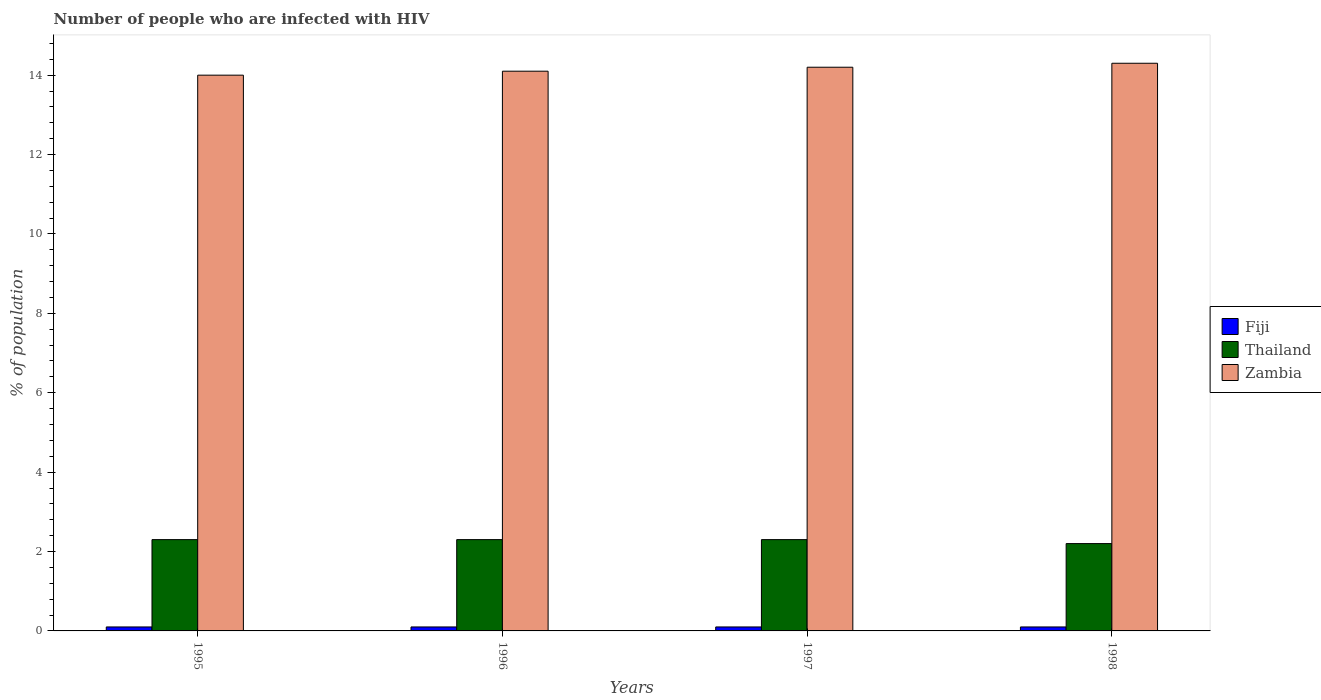How many groups of bars are there?
Keep it short and to the point. 4. Are the number of bars per tick equal to the number of legend labels?
Provide a short and direct response. Yes. Are the number of bars on each tick of the X-axis equal?
Offer a very short reply. Yes. How many bars are there on the 1st tick from the left?
Provide a succinct answer. 3. How many bars are there on the 1st tick from the right?
Offer a terse response. 3. What is the label of the 4th group of bars from the left?
Offer a terse response. 1998. Across all years, what is the maximum percentage of HIV infected population in in Zambia?
Provide a short and direct response. 14.3. Across all years, what is the minimum percentage of HIV infected population in in Zambia?
Keep it short and to the point. 14. In which year was the percentage of HIV infected population in in Thailand maximum?
Your answer should be very brief. 1995. In which year was the percentage of HIV infected population in in Fiji minimum?
Your answer should be compact. 1995. What is the total percentage of HIV infected population in in Fiji in the graph?
Your response must be concise. 0.4. What is the difference between the percentage of HIV infected population in in Fiji in 1995 and that in 1996?
Keep it short and to the point. 0. What is the average percentage of HIV infected population in in Zambia per year?
Your response must be concise. 14.15. In the year 1998, what is the difference between the percentage of HIV infected population in in Thailand and percentage of HIV infected population in in Fiji?
Your answer should be compact. 2.1. What is the ratio of the percentage of HIV infected population in in Fiji in 1995 to that in 1996?
Your response must be concise. 1. Is the difference between the percentage of HIV infected population in in Thailand in 1995 and 1996 greater than the difference between the percentage of HIV infected population in in Fiji in 1995 and 1996?
Ensure brevity in your answer.  No. In how many years, is the percentage of HIV infected population in in Thailand greater than the average percentage of HIV infected population in in Thailand taken over all years?
Ensure brevity in your answer.  3. What does the 1st bar from the left in 1998 represents?
Give a very brief answer. Fiji. What does the 1st bar from the right in 1998 represents?
Provide a short and direct response. Zambia. How many bars are there?
Provide a short and direct response. 12. Are all the bars in the graph horizontal?
Offer a terse response. No. How many years are there in the graph?
Provide a short and direct response. 4. What is the difference between two consecutive major ticks on the Y-axis?
Ensure brevity in your answer.  2. Are the values on the major ticks of Y-axis written in scientific E-notation?
Give a very brief answer. No. Where does the legend appear in the graph?
Offer a terse response. Center right. How are the legend labels stacked?
Offer a very short reply. Vertical. What is the title of the graph?
Offer a terse response. Number of people who are infected with HIV. What is the label or title of the Y-axis?
Keep it short and to the point. % of population. What is the % of population of Zambia in 1995?
Your response must be concise. 14. What is the % of population of Thailand in 1996?
Offer a very short reply. 2.3. What is the % of population in Fiji in 1998?
Your answer should be compact. 0.1. What is the % of population in Thailand in 1998?
Make the answer very short. 2.2. What is the % of population in Zambia in 1998?
Make the answer very short. 14.3. Across all years, what is the maximum % of population of Thailand?
Provide a short and direct response. 2.3. Across all years, what is the maximum % of population of Zambia?
Provide a succinct answer. 14.3. Across all years, what is the minimum % of population of Thailand?
Make the answer very short. 2.2. Across all years, what is the minimum % of population in Zambia?
Your answer should be very brief. 14. What is the total % of population in Fiji in the graph?
Your answer should be very brief. 0.4. What is the total % of population in Zambia in the graph?
Your response must be concise. 56.6. What is the difference between the % of population in Thailand in 1995 and that in 1996?
Make the answer very short. 0. What is the difference between the % of population of Zambia in 1995 and that in 1996?
Your answer should be compact. -0.1. What is the difference between the % of population in Fiji in 1995 and that in 1998?
Your answer should be very brief. 0. What is the difference between the % of population of Thailand in 1995 and that in 1998?
Your answer should be very brief. 0.1. What is the difference between the % of population of Fiji in 1996 and that in 1997?
Offer a terse response. 0. What is the difference between the % of population in Thailand in 1996 and that in 1997?
Your response must be concise. 0. What is the difference between the % of population in Zambia in 1996 and that in 1997?
Your answer should be very brief. -0.1. What is the difference between the % of population of Thailand in 1997 and that in 1998?
Offer a terse response. 0.1. What is the difference between the % of population of Thailand in 1995 and the % of population of Zambia in 1996?
Offer a terse response. -11.8. What is the difference between the % of population in Fiji in 1995 and the % of population in Zambia in 1997?
Keep it short and to the point. -14.1. What is the difference between the % of population in Fiji in 1995 and the % of population in Thailand in 1998?
Offer a very short reply. -2.1. What is the difference between the % of population of Thailand in 1995 and the % of population of Zambia in 1998?
Your response must be concise. -12. What is the difference between the % of population of Fiji in 1996 and the % of population of Thailand in 1997?
Ensure brevity in your answer.  -2.2. What is the difference between the % of population in Fiji in 1996 and the % of population in Zambia in 1997?
Make the answer very short. -14.1. What is the difference between the % of population in Fiji in 1996 and the % of population in Zambia in 1998?
Give a very brief answer. -14.2. What is the difference between the % of population in Fiji in 1997 and the % of population in Zambia in 1998?
Provide a short and direct response. -14.2. What is the average % of population of Thailand per year?
Ensure brevity in your answer.  2.27. What is the average % of population in Zambia per year?
Offer a very short reply. 14.15. In the year 1995, what is the difference between the % of population of Fiji and % of population of Zambia?
Make the answer very short. -13.9. In the year 1996, what is the difference between the % of population in Fiji and % of population in Zambia?
Offer a terse response. -14. In the year 1996, what is the difference between the % of population of Thailand and % of population of Zambia?
Provide a succinct answer. -11.8. In the year 1997, what is the difference between the % of population in Fiji and % of population in Zambia?
Give a very brief answer. -14.1. In the year 1997, what is the difference between the % of population in Thailand and % of population in Zambia?
Provide a short and direct response. -11.9. In the year 1998, what is the difference between the % of population in Fiji and % of population in Thailand?
Provide a succinct answer. -2.1. In the year 1998, what is the difference between the % of population of Thailand and % of population of Zambia?
Offer a terse response. -12.1. What is the ratio of the % of population of Zambia in 1995 to that in 1996?
Offer a very short reply. 0.99. What is the ratio of the % of population in Zambia in 1995 to that in 1997?
Ensure brevity in your answer.  0.99. What is the ratio of the % of population of Fiji in 1995 to that in 1998?
Offer a very short reply. 1. What is the ratio of the % of population in Thailand in 1995 to that in 1998?
Keep it short and to the point. 1.05. What is the ratio of the % of population in Thailand in 1996 to that in 1997?
Offer a very short reply. 1. What is the ratio of the % of population of Zambia in 1996 to that in 1997?
Provide a short and direct response. 0.99. What is the ratio of the % of population in Fiji in 1996 to that in 1998?
Provide a succinct answer. 1. What is the ratio of the % of population in Thailand in 1996 to that in 1998?
Your response must be concise. 1.05. What is the ratio of the % of population in Zambia in 1996 to that in 1998?
Make the answer very short. 0.99. What is the ratio of the % of population in Fiji in 1997 to that in 1998?
Your answer should be very brief. 1. What is the ratio of the % of population of Thailand in 1997 to that in 1998?
Give a very brief answer. 1.05. What is the difference between the highest and the second highest % of population of Fiji?
Offer a very short reply. 0. What is the difference between the highest and the second highest % of population in Zambia?
Your answer should be compact. 0.1. What is the difference between the highest and the lowest % of population in Thailand?
Give a very brief answer. 0.1. 